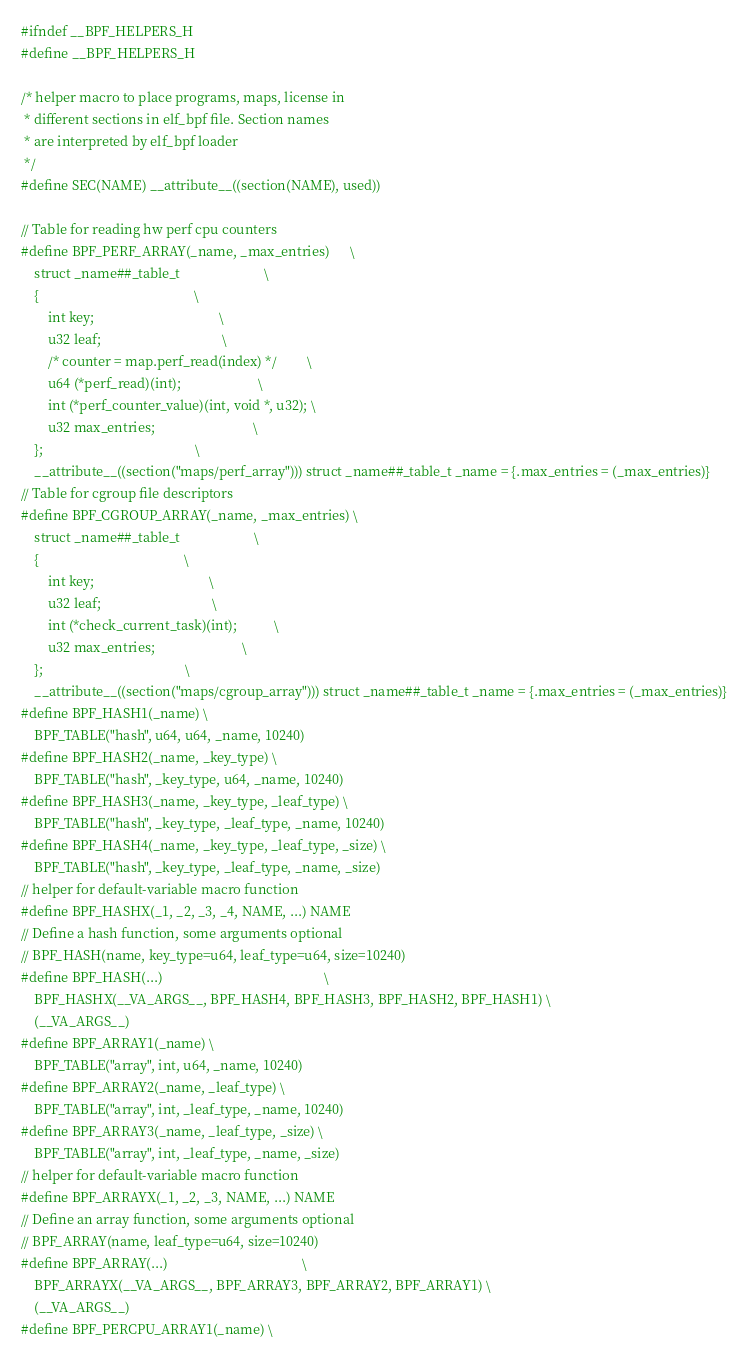Convert code to text. <code><loc_0><loc_0><loc_500><loc_500><_C_>#ifndef __BPF_HELPERS_H
#define __BPF_HELPERS_H

/* helper macro to place programs, maps, license in
 * different sections in elf_bpf file. Section names
 * are interpreted by elf_bpf loader
 */
#define SEC(NAME) __attribute__((section(NAME), used))

// Table for reading hw perf cpu counters
#define BPF_PERF_ARRAY(_name, _max_entries)      \
	struct _name##_table_t                         \
	{                                              \
		int key;                                     \
		u32 leaf;                                    \
		/* counter = map.perf_read(index) */         \
		u64 (*perf_read)(int);                       \
		int (*perf_counter_value)(int, void *, u32); \
		u32 max_entries;                             \
	};                                             \
	__attribute__((section("maps/perf_array"))) struct _name##_table_t _name = {.max_entries = (_max_entries)}
// Table for cgroup file descriptors
#define BPF_CGROUP_ARRAY(_name, _max_entries) \
	struct _name##_table_t                      \
	{                                           \
		int key;                                  \
		u32 leaf;                                 \
		int (*check_current_task)(int);           \
		u32 max_entries;                          \
	};                                          \
	__attribute__((section("maps/cgroup_array"))) struct _name##_table_t _name = {.max_entries = (_max_entries)}
#define BPF_HASH1(_name) \
	BPF_TABLE("hash", u64, u64, _name, 10240)
#define BPF_HASH2(_name, _key_type) \
	BPF_TABLE("hash", _key_type, u64, _name, 10240)
#define BPF_HASH3(_name, _key_type, _leaf_type) \
	BPF_TABLE("hash", _key_type, _leaf_type, _name, 10240)
#define BPF_HASH4(_name, _key_type, _leaf_type, _size) \
	BPF_TABLE("hash", _key_type, _leaf_type, _name, _size)
// helper for default-variable macro function
#define BPF_HASHX(_1, _2, _3, _4, NAME, ...) NAME
// Define a hash function, some arguments optional
// BPF_HASH(name, key_type=u64, leaf_type=u64, size=10240)
#define BPF_HASH(...)                                                \
	BPF_HASHX(__VA_ARGS__, BPF_HASH4, BPF_HASH3, BPF_HASH2, BPF_HASH1) \
	(__VA_ARGS__)
#define BPF_ARRAY1(_name) \
	BPF_TABLE("array", int, u64, _name, 10240)
#define BPF_ARRAY2(_name, _leaf_type) \
	BPF_TABLE("array", int, _leaf_type, _name, 10240)
#define BPF_ARRAY3(_name, _leaf_type, _size) \
	BPF_TABLE("array", int, _leaf_type, _name, _size)
// helper for default-variable macro function
#define BPF_ARRAYX(_1, _2, _3, NAME, ...) NAME
// Define an array function, some arguments optional
// BPF_ARRAY(name, leaf_type=u64, size=10240)
#define BPF_ARRAY(...)                                        \
	BPF_ARRAYX(__VA_ARGS__, BPF_ARRAY3, BPF_ARRAY2, BPF_ARRAY1) \
	(__VA_ARGS__)
#define BPF_PERCPU_ARRAY1(_name) \</code> 